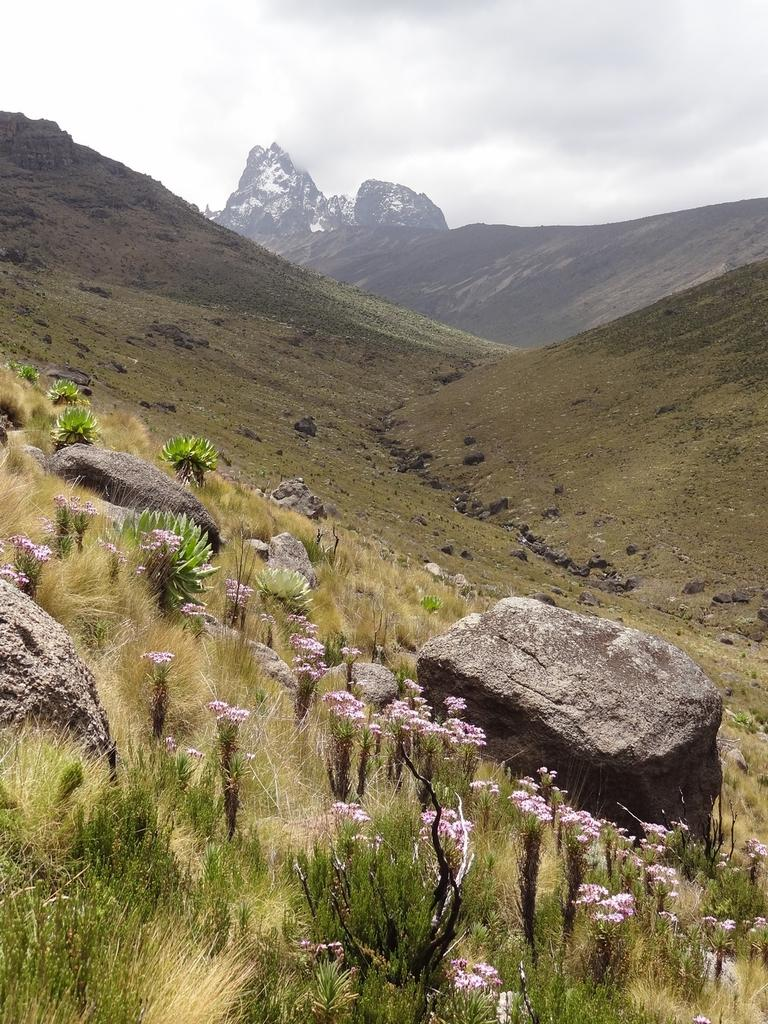What types of plants can be seen in the foreground of the image? There are flowers and plants in the foreground of the image. What other elements are present in the foreground of the image? There are stones and grass in the foreground of the image. What geographical features can be seen in the middle of the image? There are hills and mountains in the middle of the image. What part of the natural environment is visible at the top of the image? The sky is visible at the top of the image. What type of creature is leading the team up the mountain in the image? There is no creature or team present in the image; it features plants, stones, grass, hills, mountains, and the sky. 